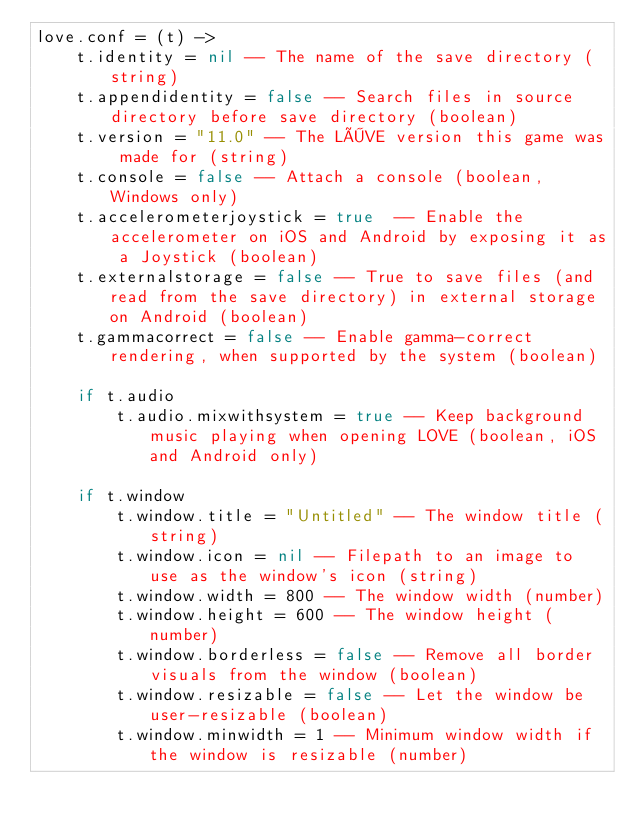<code> <loc_0><loc_0><loc_500><loc_500><_MoonScript_>love.conf = (t) ->
	t.identity = nil -- The name of the save directory (string)
	t.appendidentity = false -- Search files in source directory before save directory (boolean)
	t.version = "11.0" -- The LÖVE version this game was made for (string)
	t.console = false -- Attach a console (boolean, Windows only)
	t.accelerometerjoystick = true  -- Enable the accelerometer on iOS and Android by exposing it as a Joystick (boolean)
	t.externalstorage = false -- True to save files (and read from the save directory) in external storage on Android (boolean) 
	t.gammacorrect = false -- Enable gamma-correct rendering, when supported by the system (boolean)

	if t.audio
		t.audio.mixwithsystem = true -- Keep background music playing when opening LOVE (boolean, iOS and Android only)

	if t.window
		t.window.title = "Untitled" -- The window title (string)
		t.window.icon = nil -- Filepath to an image to use as the window's icon (string)
		t.window.width = 800 -- The window width (number)
		t.window.height = 600 -- The window height (number)
		t.window.borderless = false -- Remove all border visuals from the window (boolean)
		t.window.resizable = false -- Let the window be user-resizable (boolean)
		t.window.minwidth = 1 -- Minimum window width if the window is resizable (number)</code> 